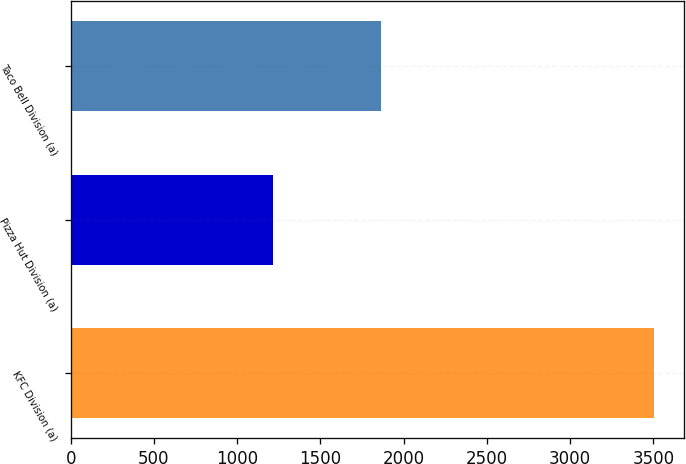Convert chart. <chart><loc_0><loc_0><loc_500><loc_500><bar_chart><fcel>KFC Division (a)<fcel>Pizza Hut Division (a)<fcel>Taco Bell Division (a)<nl><fcel>3507<fcel>1215<fcel>1865<nl></chart> 